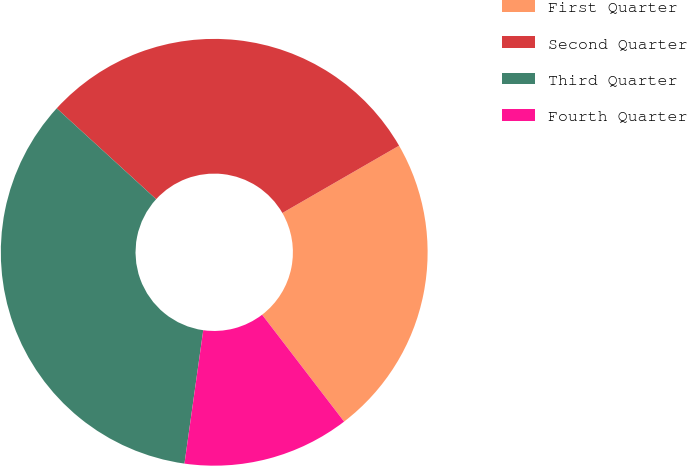Convert chart to OTSL. <chart><loc_0><loc_0><loc_500><loc_500><pie_chart><fcel>First Quarter<fcel>Second Quarter<fcel>Third Quarter<fcel>Fourth Quarter<nl><fcel>22.91%<fcel>29.89%<fcel>34.56%<fcel>12.64%<nl></chart> 